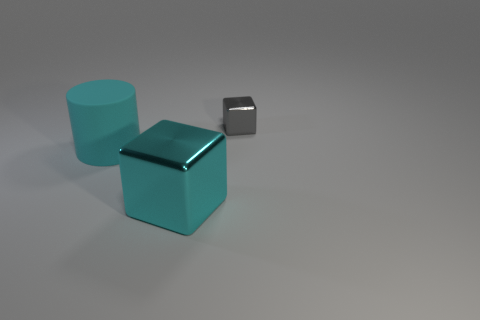Add 1 large yellow rubber cylinders. How many objects exist? 4 Subtract all cylinders. How many objects are left? 2 Subtract all cyan cylinders. Subtract all blue rubber balls. How many objects are left? 2 Add 2 large cyan cylinders. How many large cyan cylinders are left? 3 Add 2 cyan matte cylinders. How many cyan matte cylinders exist? 3 Subtract 0 green blocks. How many objects are left? 3 